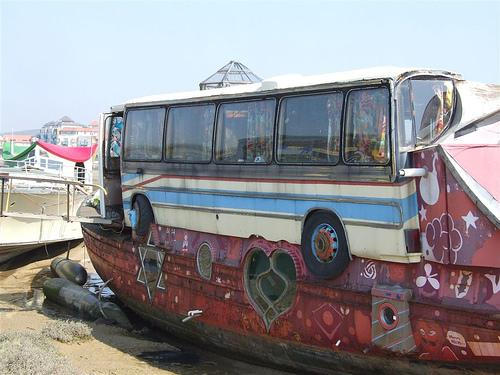What do people most likely do in the structure? Please explain your reasoning. sleep. A person has somehow made boat into a house and has curtains for privacy. 